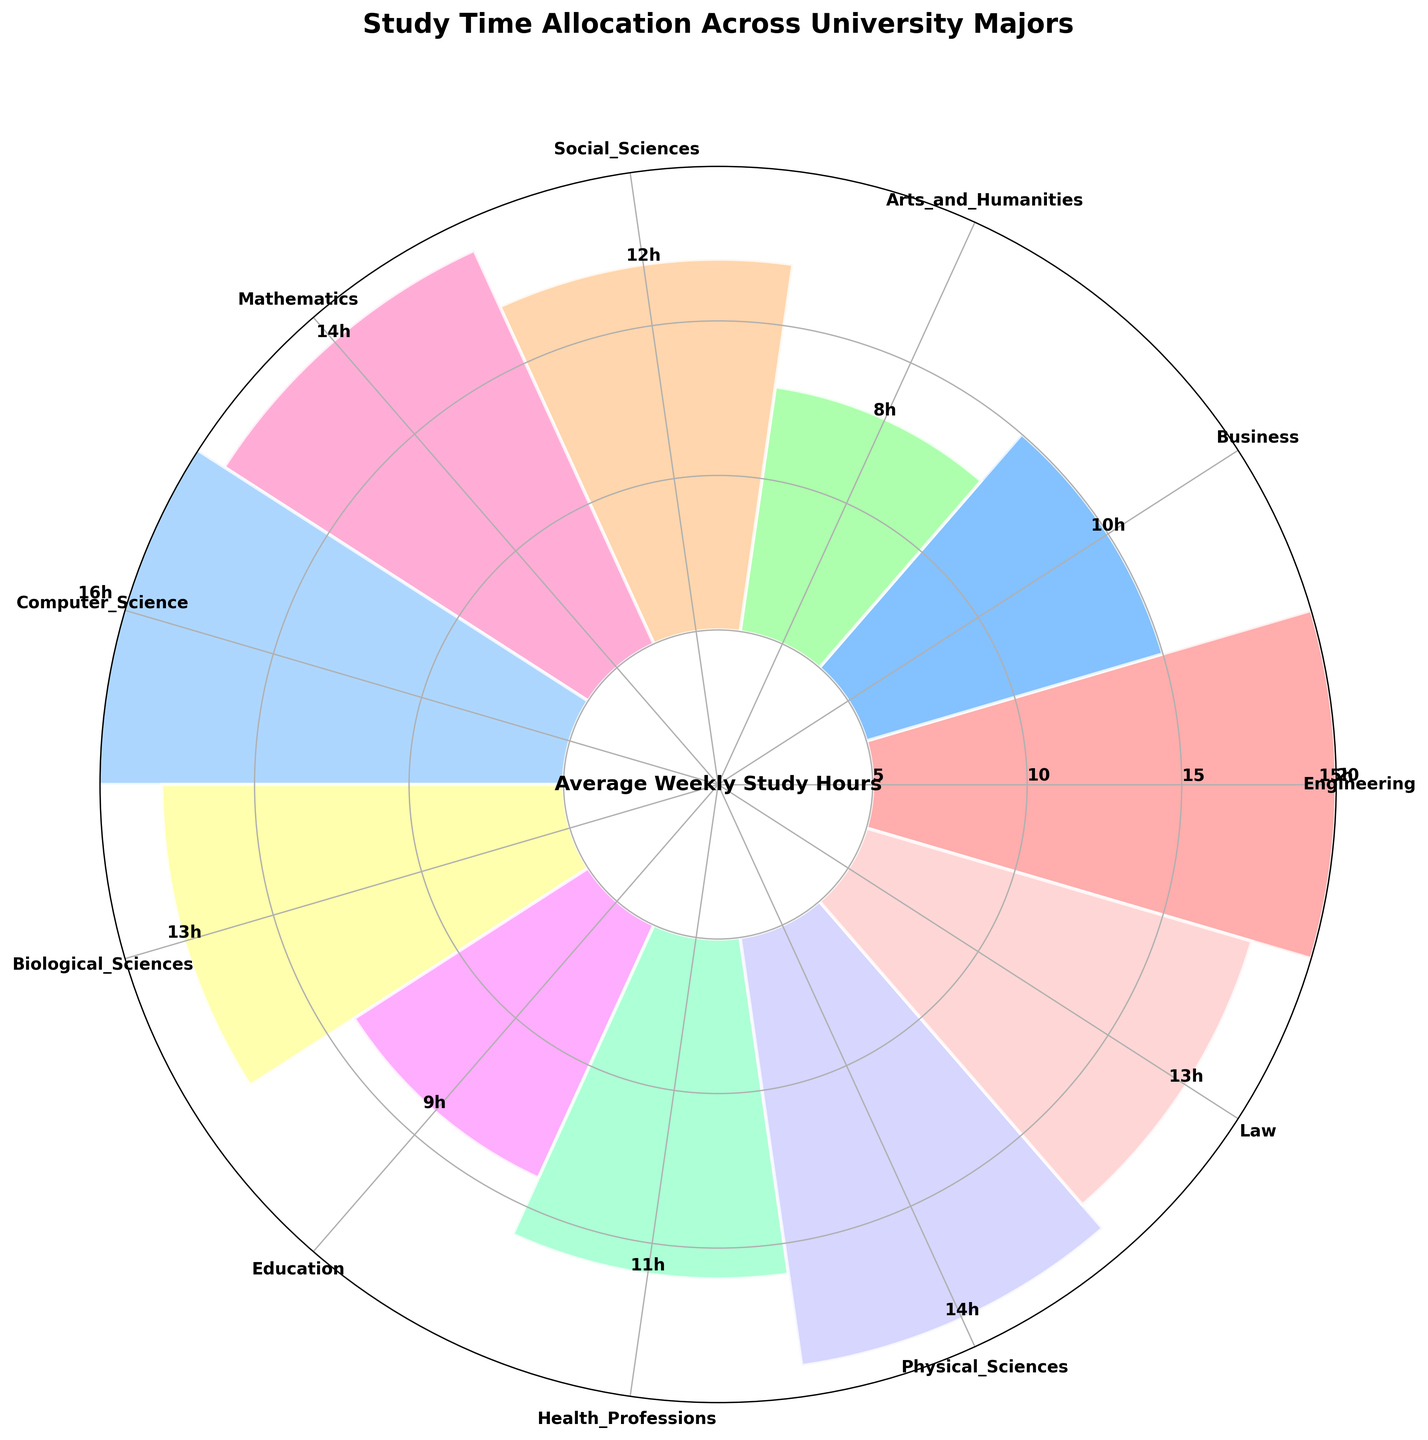What is the range of study hours in the figure? To find the range, we need to subtract the shortest study time from the longest study time. The shortest study time is 8 hours (Arts and Humanities) and the longest is 16 hours (Computer Science). Thus, the range is 16 - 8 = 8 hours.
Answer: 8 hours Which major has the highest average weekly study hours? By looking at the bars in the rose chart, we can see that the longest bar corresponds to Computer Science, which has 16 hours.
Answer: Computer Science Which major has the lowest average weekly study hours, and how many hours is it? By observing the shortest bar in the rose chart, we find that Arts and Humanities has the lowest study hours, which is 8 hours.
Answer: Arts and Humanities, 8 hours What is the sum of study hours for Engineering and Mathematics? Engineering has 15 hours and Mathematics has 14 hours. Adding these together, 15 + 14 = 29 hours.
Answer: 29 hours How many majors have study hours greater than 12? The majors are Computer Science (16), Engineering (15), Mathematics (14), Physical Sciences (14), and Biological Sciences (13). Thus, there are 5 majors with study hours greater than 12.
Answer: 5 How is the study time different between Business and Health Professions majors? Business majors spend 10 hours while Health Professions majors spend 11 hours. The difference is 11 - 10 = 1 hour.
Answer: 1 hour What is the average study time of all the majors? Sum all study hours: 15+10+8+12+14+16+13+9+11+14+13 = 135. There are 11 majors, so the average is 135 / 11 ≈ 12.27 hours.
Answer: ~12.27 hours Which majors fall in the middle in terms of study hours (median value)? First, list the hours in ascending order: 8, 9, 10, 11, 12, 13, 13, 14, 14, 15, 16. The median value is the 6th value, so the median is 13 hours, which corresponds to Law and Biological Sciences majors.
Answer: Law, Biological Sciences Compare the combined study hours for Education and Social Sciences to Computer Science. Which is greater? Education has 9 hours and Social Sciences has 12 hours. Combined, they have 9 + 12 = 21 hours. Computer Science has 16 hours. Thus, the combined study hours for Education and Social Sciences are greater.
Answer: Combined Education and Social Sciences What is the relative difference in study hours between Physical Sciences and Biological Sciences? Physical Sciences have 14 hours and Biological Sciences have 13 hours. The relative difference is (14 - 13) / 13 * 100% ≈ 7.69%
Answer: ~7.69% 